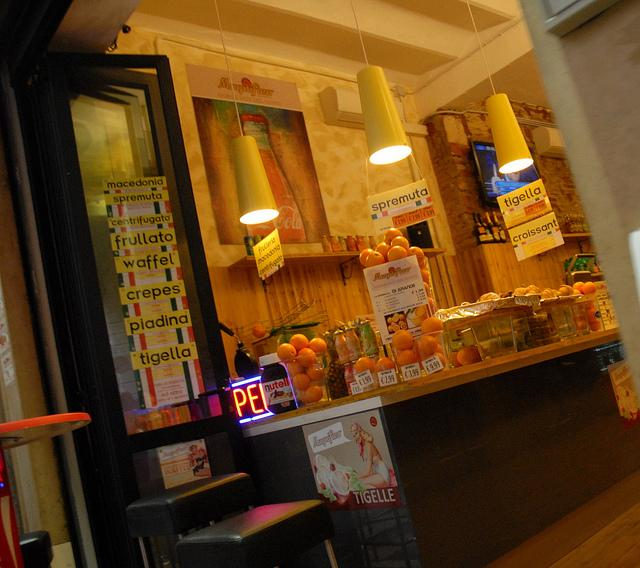What do people do here? Please explain your reasoning. eat. People eat here. 